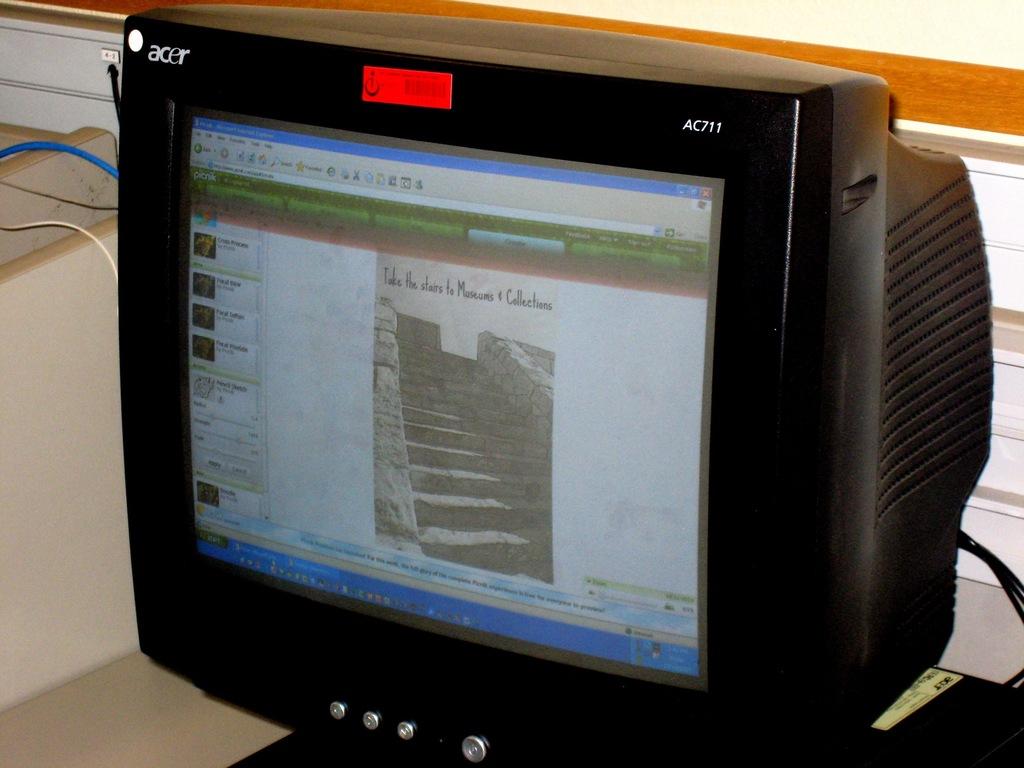What company made the computer moniter?
Offer a very short reply. Acer. What is the brand name printed on the top left of the monitor?
Ensure brevity in your answer.  Acer. 